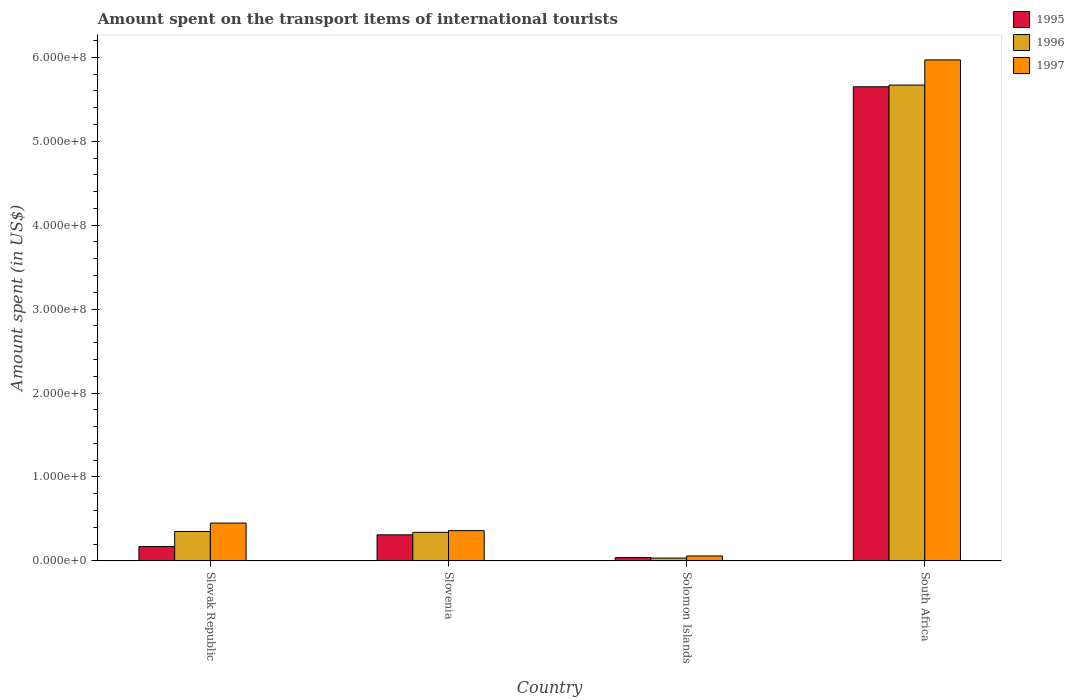How many different coloured bars are there?
Give a very brief answer. 3. Are the number of bars on each tick of the X-axis equal?
Make the answer very short. Yes. How many bars are there on the 3rd tick from the left?
Offer a terse response. 3. How many bars are there on the 3rd tick from the right?
Give a very brief answer. 3. What is the label of the 2nd group of bars from the left?
Provide a short and direct response. Slovenia. What is the amount spent on the transport items of international tourists in 1995 in Slovenia?
Ensure brevity in your answer.  3.10e+07. Across all countries, what is the maximum amount spent on the transport items of international tourists in 1996?
Your response must be concise. 5.67e+08. Across all countries, what is the minimum amount spent on the transport items of international tourists in 1995?
Provide a succinct answer. 3.90e+06. In which country was the amount spent on the transport items of international tourists in 1995 maximum?
Provide a succinct answer. South Africa. In which country was the amount spent on the transport items of international tourists in 1996 minimum?
Give a very brief answer. Solomon Islands. What is the total amount spent on the transport items of international tourists in 1997 in the graph?
Offer a very short reply. 6.84e+08. What is the difference between the amount spent on the transport items of international tourists in 1996 in Slovenia and that in South Africa?
Offer a terse response. -5.33e+08. What is the difference between the amount spent on the transport items of international tourists in 1996 in South Africa and the amount spent on the transport items of international tourists in 1995 in Slovenia?
Make the answer very short. 5.36e+08. What is the average amount spent on the transport items of international tourists in 1995 per country?
Your answer should be compact. 1.54e+08. What is the difference between the amount spent on the transport items of international tourists of/in 1995 and amount spent on the transport items of international tourists of/in 1997 in South Africa?
Provide a short and direct response. -3.20e+07. What is the ratio of the amount spent on the transport items of international tourists in 1995 in Slovak Republic to that in Slovenia?
Offer a very short reply. 0.55. Is the amount spent on the transport items of international tourists in 1995 in Slovak Republic less than that in Solomon Islands?
Offer a very short reply. No. What is the difference between the highest and the second highest amount spent on the transport items of international tourists in 1995?
Keep it short and to the point. 5.48e+08. What is the difference between the highest and the lowest amount spent on the transport items of international tourists in 1995?
Offer a terse response. 5.61e+08. In how many countries, is the amount spent on the transport items of international tourists in 1995 greater than the average amount spent on the transport items of international tourists in 1995 taken over all countries?
Your answer should be compact. 1. What does the 2nd bar from the left in Slovenia represents?
Your response must be concise. 1996. Is it the case that in every country, the sum of the amount spent on the transport items of international tourists in 1997 and amount spent on the transport items of international tourists in 1995 is greater than the amount spent on the transport items of international tourists in 1996?
Give a very brief answer. Yes. How many bars are there?
Ensure brevity in your answer.  12. How many countries are there in the graph?
Give a very brief answer. 4. What is the difference between two consecutive major ticks on the Y-axis?
Give a very brief answer. 1.00e+08. Are the values on the major ticks of Y-axis written in scientific E-notation?
Ensure brevity in your answer.  Yes. Does the graph contain any zero values?
Ensure brevity in your answer.  No. Does the graph contain grids?
Keep it short and to the point. No. Where does the legend appear in the graph?
Give a very brief answer. Top right. What is the title of the graph?
Offer a very short reply. Amount spent on the transport items of international tourists. Does "2014" appear as one of the legend labels in the graph?
Your answer should be very brief. No. What is the label or title of the Y-axis?
Provide a succinct answer. Amount spent (in US$). What is the Amount spent (in US$) of 1995 in Slovak Republic?
Make the answer very short. 1.70e+07. What is the Amount spent (in US$) in 1996 in Slovak Republic?
Ensure brevity in your answer.  3.50e+07. What is the Amount spent (in US$) of 1997 in Slovak Republic?
Keep it short and to the point. 4.50e+07. What is the Amount spent (in US$) of 1995 in Slovenia?
Make the answer very short. 3.10e+07. What is the Amount spent (in US$) in 1996 in Slovenia?
Provide a succinct answer. 3.40e+07. What is the Amount spent (in US$) of 1997 in Slovenia?
Your answer should be compact. 3.60e+07. What is the Amount spent (in US$) in 1995 in Solomon Islands?
Provide a short and direct response. 3.90e+06. What is the Amount spent (in US$) of 1996 in Solomon Islands?
Your response must be concise. 3.30e+06. What is the Amount spent (in US$) in 1997 in Solomon Islands?
Provide a short and direct response. 5.80e+06. What is the Amount spent (in US$) of 1995 in South Africa?
Your answer should be compact. 5.65e+08. What is the Amount spent (in US$) in 1996 in South Africa?
Provide a short and direct response. 5.67e+08. What is the Amount spent (in US$) of 1997 in South Africa?
Offer a very short reply. 5.97e+08. Across all countries, what is the maximum Amount spent (in US$) in 1995?
Your response must be concise. 5.65e+08. Across all countries, what is the maximum Amount spent (in US$) of 1996?
Your answer should be very brief. 5.67e+08. Across all countries, what is the maximum Amount spent (in US$) of 1997?
Your response must be concise. 5.97e+08. Across all countries, what is the minimum Amount spent (in US$) of 1995?
Your answer should be compact. 3.90e+06. Across all countries, what is the minimum Amount spent (in US$) in 1996?
Give a very brief answer. 3.30e+06. Across all countries, what is the minimum Amount spent (in US$) of 1997?
Your answer should be compact. 5.80e+06. What is the total Amount spent (in US$) in 1995 in the graph?
Keep it short and to the point. 6.17e+08. What is the total Amount spent (in US$) in 1996 in the graph?
Your answer should be very brief. 6.39e+08. What is the total Amount spent (in US$) in 1997 in the graph?
Your response must be concise. 6.84e+08. What is the difference between the Amount spent (in US$) in 1995 in Slovak Republic and that in Slovenia?
Your answer should be compact. -1.40e+07. What is the difference between the Amount spent (in US$) in 1997 in Slovak Republic and that in Slovenia?
Your answer should be very brief. 9.00e+06. What is the difference between the Amount spent (in US$) in 1995 in Slovak Republic and that in Solomon Islands?
Keep it short and to the point. 1.31e+07. What is the difference between the Amount spent (in US$) in 1996 in Slovak Republic and that in Solomon Islands?
Make the answer very short. 3.17e+07. What is the difference between the Amount spent (in US$) in 1997 in Slovak Republic and that in Solomon Islands?
Give a very brief answer. 3.92e+07. What is the difference between the Amount spent (in US$) of 1995 in Slovak Republic and that in South Africa?
Keep it short and to the point. -5.48e+08. What is the difference between the Amount spent (in US$) in 1996 in Slovak Republic and that in South Africa?
Offer a terse response. -5.32e+08. What is the difference between the Amount spent (in US$) of 1997 in Slovak Republic and that in South Africa?
Provide a short and direct response. -5.52e+08. What is the difference between the Amount spent (in US$) of 1995 in Slovenia and that in Solomon Islands?
Give a very brief answer. 2.71e+07. What is the difference between the Amount spent (in US$) of 1996 in Slovenia and that in Solomon Islands?
Provide a short and direct response. 3.07e+07. What is the difference between the Amount spent (in US$) in 1997 in Slovenia and that in Solomon Islands?
Make the answer very short. 3.02e+07. What is the difference between the Amount spent (in US$) in 1995 in Slovenia and that in South Africa?
Provide a succinct answer. -5.34e+08. What is the difference between the Amount spent (in US$) in 1996 in Slovenia and that in South Africa?
Give a very brief answer. -5.33e+08. What is the difference between the Amount spent (in US$) in 1997 in Slovenia and that in South Africa?
Keep it short and to the point. -5.61e+08. What is the difference between the Amount spent (in US$) of 1995 in Solomon Islands and that in South Africa?
Your response must be concise. -5.61e+08. What is the difference between the Amount spent (in US$) of 1996 in Solomon Islands and that in South Africa?
Ensure brevity in your answer.  -5.64e+08. What is the difference between the Amount spent (in US$) of 1997 in Solomon Islands and that in South Africa?
Keep it short and to the point. -5.91e+08. What is the difference between the Amount spent (in US$) of 1995 in Slovak Republic and the Amount spent (in US$) of 1996 in Slovenia?
Offer a terse response. -1.70e+07. What is the difference between the Amount spent (in US$) of 1995 in Slovak Republic and the Amount spent (in US$) of 1997 in Slovenia?
Give a very brief answer. -1.90e+07. What is the difference between the Amount spent (in US$) of 1996 in Slovak Republic and the Amount spent (in US$) of 1997 in Slovenia?
Ensure brevity in your answer.  -1.00e+06. What is the difference between the Amount spent (in US$) of 1995 in Slovak Republic and the Amount spent (in US$) of 1996 in Solomon Islands?
Your response must be concise. 1.37e+07. What is the difference between the Amount spent (in US$) in 1995 in Slovak Republic and the Amount spent (in US$) in 1997 in Solomon Islands?
Give a very brief answer. 1.12e+07. What is the difference between the Amount spent (in US$) of 1996 in Slovak Republic and the Amount spent (in US$) of 1997 in Solomon Islands?
Offer a very short reply. 2.92e+07. What is the difference between the Amount spent (in US$) in 1995 in Slovak Republic and the Amount spent (in US$) in 1996 in South Africa?
Keep it short and to the point. -5.50e+08. What is the difference between the Amount spent (in US$) in 1995 in Slovak Republic and the Amount spent (in US$) in 1997 in South Africa?
Your response must be concise. -5.80e+08. What is the difference between the Amount spent (in US$) of 1996 in Slovak Republic and the Amount spent (in US$) of 1997 in South Africa?
Your answer should be compact. -5.62e+08. What is the difference between the Amount spent (in US$) of 1995 in Slovenia and the Amount spent (in US$) of 1996 in Solomon Islands?
Your response must be concise. 2.77e+07. What is the difference between the Amount spent (in US$) in 1995 in Slovenia and the Amount spent (in US$) in 1997 in Solomon Islands?
Your response must be concise. 2.52e+07. What is the difference between the Amount spent (in US$) of 1996 in Slovenia and the Amount spent (in US$) of 1997 in Solomon Islands?
Your response must be concise. 2.82e+07. What is the difference between the Amount spent (in US$) in 1995 in Slovenia and the Amount spent (in US$) in 1996 in South Africa?
Give a very brief answer. -5.36e+08. What is the difference between the Amount spent (in US$) in 1995 in Slovenia and the Amount spent (in US$) in 1997 in South Africa?
Offer a terse response. -5.66e+08. What is the difference between the Amount spent (in US$) of 1996 in Slovenia and the Amount spent (in US$) of 1997 in South Africa?
Give a very brief answer. -5.63e+08. What is the difference between the Amount spent (in US$) in 1995 in Solomon Islands and the Amount spent (in US$) in 1996 in South Africa?
Make the answer very short. -5.63e+08. What is the difference between the Amount spent (in US$) of 1995 in Solomon Islands and the Amount spent (in US$) of 1997 in South Africa?
Your answer should be compact. -5.93e+08. What is the difference between the Amount spent (in US$) of 1996 in Solomon Islands and the Amount spent (in US$) of 1997 in South Africa?
Offer a terse response. -5.94e+08. What is the average Amount spent (in US$) in 1995 per country?
Offer a very short reply. 1.54e+08. What is the average Amount spent (in US$) of 1996 per country?
Keep it short and to the point. 1.60e+08. What is the average Amount spent (in US$) of 1997 per country?
Offer a terse response. 1.71e+08. What is the difference between the Amount spent (in US$) of 1995 and Amount spent (in US$) of 1996 in Slovak Republic?
Make the answer very short. -1.80e+07. What is the difference between the Amount spent (in US$) of 1995 and Amount spent (in US$) of 1997 in Slovak Republic?
Give a very brief answer. -2.80e+07. What is the difference between the Amount spent (in US$) in 1996 and Amount spent (in US$) in 1997 in Slovak Republic?
Give a very brief answer. -1.00e+07. What is the difference between the Amount spent (in US$) in 1995 and Amount spent (in US$) in 1997 in Slovenia?
Keep it short and to the point. -5.00e+06. What is the difference between the Amount spent (in US$) of 1995 and Amount spent (in US$) of 1997 in Solomon Islands?
Keep it short and to the point. -1.90e+06. What is the difference between the Amount spent (in US$) in 1996 and Amount spent (in US$) in 1997 in Solomon Islands?
Make the answer very short. -2.50e+06. What is the difference between the Amount spent (in US$) in 1995 and Amount spent (in US$) in 1996 in South Africa?
Your response must be concise. -2.00e+06. What is the difference between the Amount spent (in US$) of 1995 and Amount spent (in US$) of 1997 in South Africa?
Make the answer very short. -3.20e+07. What is the difference between the Amount spent (in US$) of 1996 and Amount spent (in US$) of 1997 in South Africa?
Ensure brevity in your answer.  -3.00e+07. What is the ratio of the Amount spent (in US$) in 1995 in Slovak Republic to that in Slovenia?
Your response must be concise. 0.55. What is the ratio of the Amount spent (in US$) in 1996 in Slovak Republic to that in Slovenia?
Keep it short and to the point. 1.03. What is the ratio of the Amount spent (in US$) of 1997 in Slovak Republic to that in Slovenia?
Your answer should be very brief. 1.25. What is the ratio of the Amount spent (in US$) in 1995 in Slovak Republic to that in Solomon Islands?
Give a very brief answer. 4.36. What is the ratio of the Amount spent (in US$) in 1996 in Slovak Republic to that in Solomon Islands?
Keep it short and to the point. 10.61. What is the ratio of the Amount spent (in US$) of 1997 in Slovak Republic to that in Solomon Islands?
Your answer should be compact. 7.76. What is the ratio of the Amount spent (in US$) of 1995 in Slovak Republic to that in South Africa?
Ensure brevity in your answer.  0.03. What is the ratio of the Amount spent (in US$) in 1996 in Slovak Republic to that in South Africa?
Provide a short and direct response. 0.06. What is the ratio of the Amount spent (in US$) of 1997 in Slovak Republic to that in South Africa?
Your response must be concise. 0.08. What is the ratio of the Amount spent (in US$) in 1995 in Slovenia to that in Solomon Islands?
Your answer should be very brief. 7.95. What is the ratio of the Amount spent (in US$) of 1996 in Slovenia to that in Solomon Islands?
Give a very brief answer. 10.3. What is the ratio of the Amount spent (in US$) of 1997 in Slovenia to that in Solomon Islands?
Offer a terse response. 6.21. What is the ratio of the Amount spent (in US$) in 1995 in Slovenia to that in South Africa?
Make the answer very short. 0.05. What is the ratio of the Amount spent (in US$) in 1997 in Slovenia to that in South Africa?
Make the answer very short. 0.06. What is the ratio of the Amount spent (in US$) of 1995 in Solomon Islands to that in South Africa?
Ensure brevity in your answer.  0.01. What is the ratio of the Amount spent (in US$) in 1996 in Solomon Islands to that in South Africa?
Ensure brevity in your answer.  0.01. What is the ratio of the Amount spent (in US$) in 1997 in Solomon Islands to that in South Africa?
Make the answer very short. 0.01. What is the difference between the highest and the second highest Amount spent (in US$) in 1995?
Provide a short and direct response. 5.34e+08. What is the difference between the highest and the second highest Amount spent (in US$) of 1996?
Make the answer very short. 5.32e+08. What is the difference between the highest and the second highest Amount spent (in US$) in 1997?
Offer a terse response. 5.52e+08. What is the difference between the highest and the lowest Amount spent (in US$) of 1995?
Give a very brief answer. 5.61e+08. What is the difference between the highest and the lowest Amount spent (in US$) of 1996?
Make the answer very short. 5.64e+08. What is the difference between the highest and the lowest Amount spent (in US$) in 1997?
Offer a very short reply. 5.91e+08. 